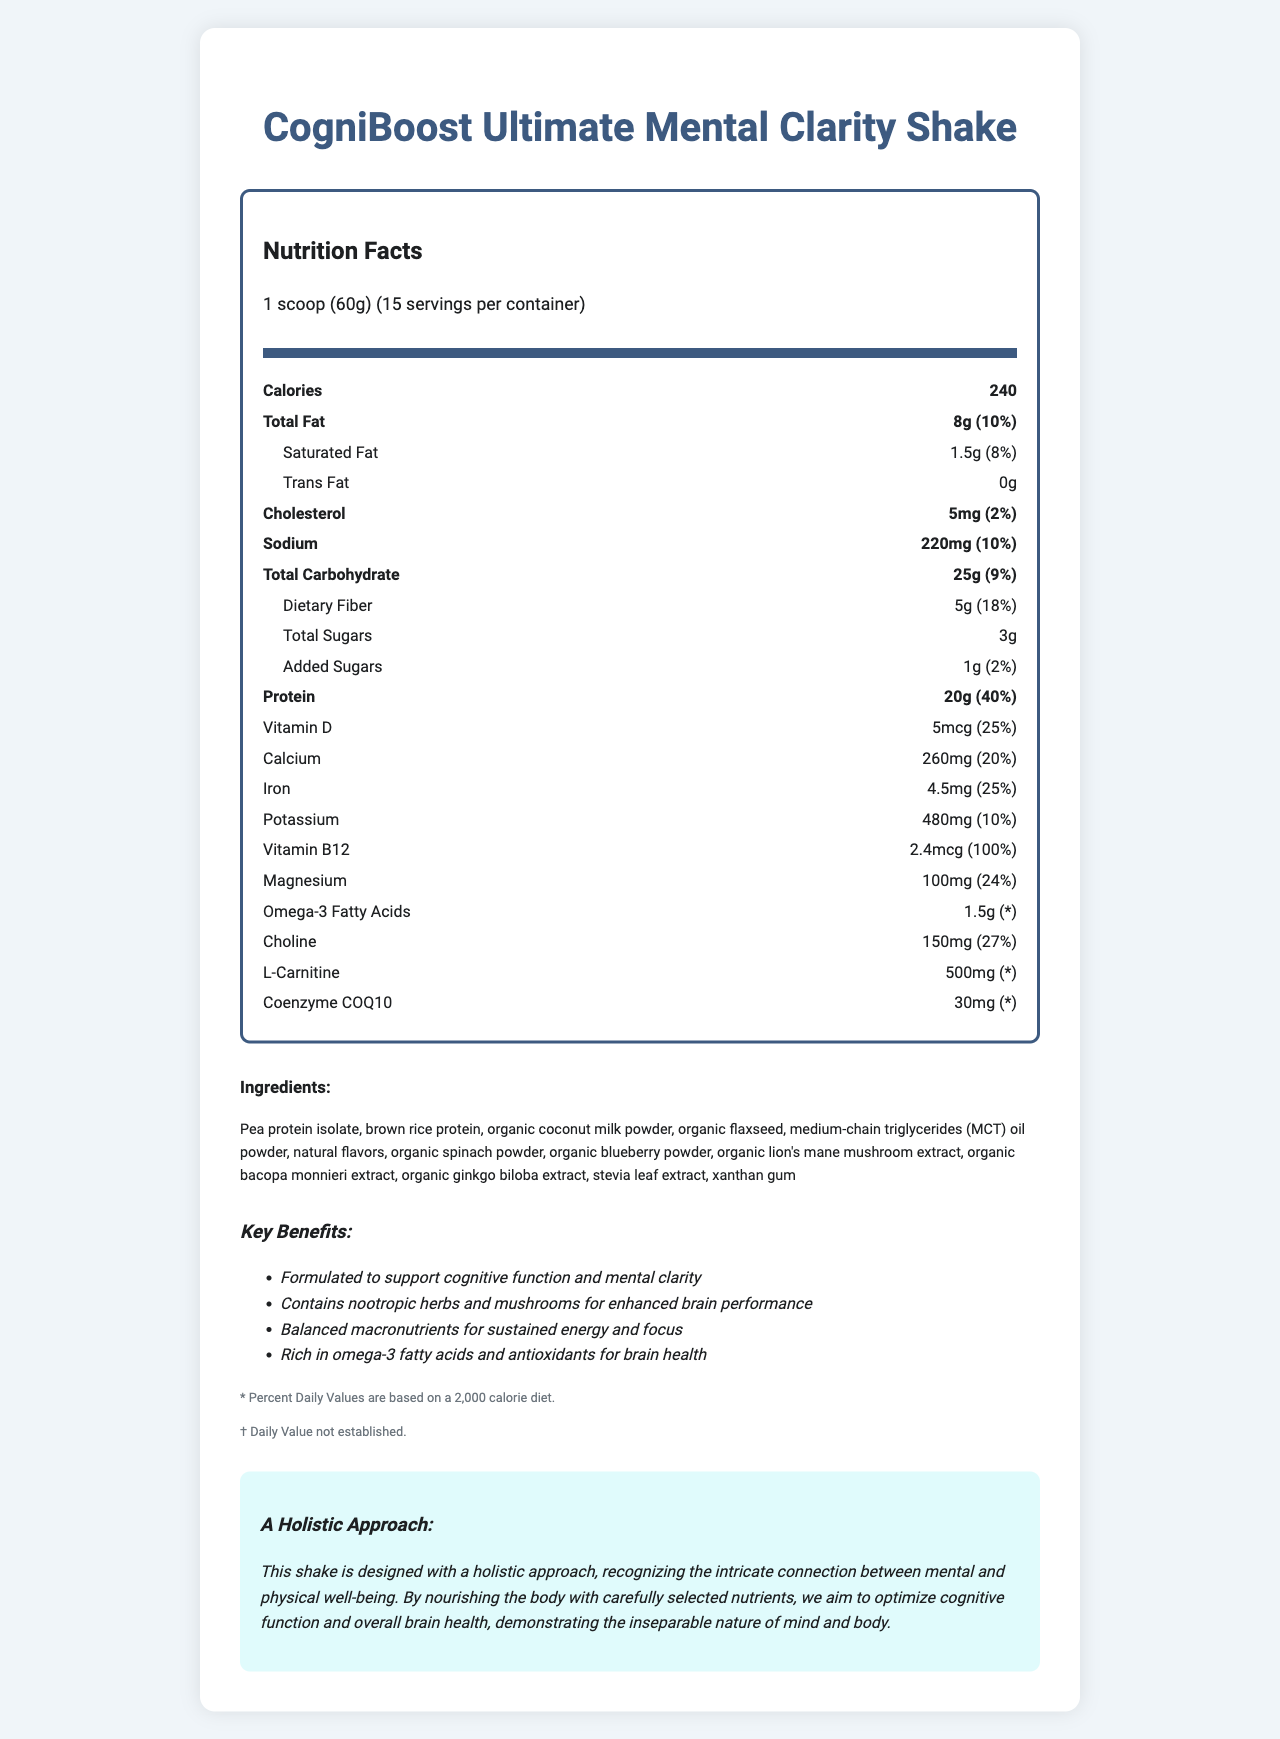what is the serving size? The serving size is listed under the "Nutrition Facts" section, next to the label "servingSize".
Answer: 1 scoop (60g) how many calories are in one serving? The number of calories per serving is found under the main "Calories" label in the Nutrition Facts section.
Answer: 240 how much total fat does one serving contain in grams? The document lists the total fat content as 8g in the Nutrition Facts section.
Answer: 8g what percent of the daily value of cholesterol is in one serving? The daily value percentage for cholesterol is clearly indicated as 2% in the Nutrition Facts section.
Answer: 2% how many grams of dietary fiber are in one serving? The document specifies that the dietary fiber content per serving is 5g, located under the total carbohydrate section in the Nutrition Facts.
Answer: 5g which nutrient has the highest percentage of the daily value in one serving? A. Iron B. Vitamin D C. Protein D. Vitamin B12 Vitamin B12 has the highest daily value percentage at 100%, as listed in the Nutrition Facts section.
Answer: D what macronutrient is most predominant in the shake? A. Protein B. Carbohydrate C. Fat Protein is most predominant with 20g per serving, while total carbohydrate is 25g but protein has a higher daily value percentage indicating a balanced formula.
Answer: A does the shake contain any tree nuts? The allergen statement indicates that the shake contains tree nuts (coconut).
Answer: Yes how many servings are in one container? The number of servings per container is listed as 15 in the serving info section.
Answer: 15 which of the following are key benefits of the shake? I. Supports cognitive function II. High in sodium III. Contains antioxidants A. I only B. I and III only C. III only The key benefits include supporting cognitive function and containing antioxidants, but it doesn't boast about being high in sodium.
Answer: B what statement reflects the product's monistic perspective? This statement is provided under the section "A Holistic Approach" and clearly reflects the monistic perspective.
Answer: "This shake is designed with a holistic approach, recognizing the intricate connection between mental and physical well-being. By nourishing the body with carefully selected nutrients, we aim to optimize cognitive function and overall brain health, demonstrating the inseparable nature of mind and body." what is the primary protein source in this shake? These ingredients are listed first in the ingredients section, indicating their prevalence as the primary protein sources.
Answer: Pea protein isolate and brown rice protein who is the target audience for the CogniBoost Ultimate Mental Clarity Shake? The document doesn't provide specific information about the target audience demographics.
Answer: Cannot be determined summarize the main idea of the document. The summary is derived from the various sections of the document, including nutritional content, ingredient list, key claims, and the monistic perspective statement.
Answer: The document details the Nutrition Facts and ingredients of the CogniBoost Ultimate Mental Clarity Shake, highlighting its nutritional content geared towards supporting cognitive functions and mental clarity. It includes claims about balanced macronutrients, omega-3 fatty acids, and the holistic approach to linking physical well-being with mental health. 